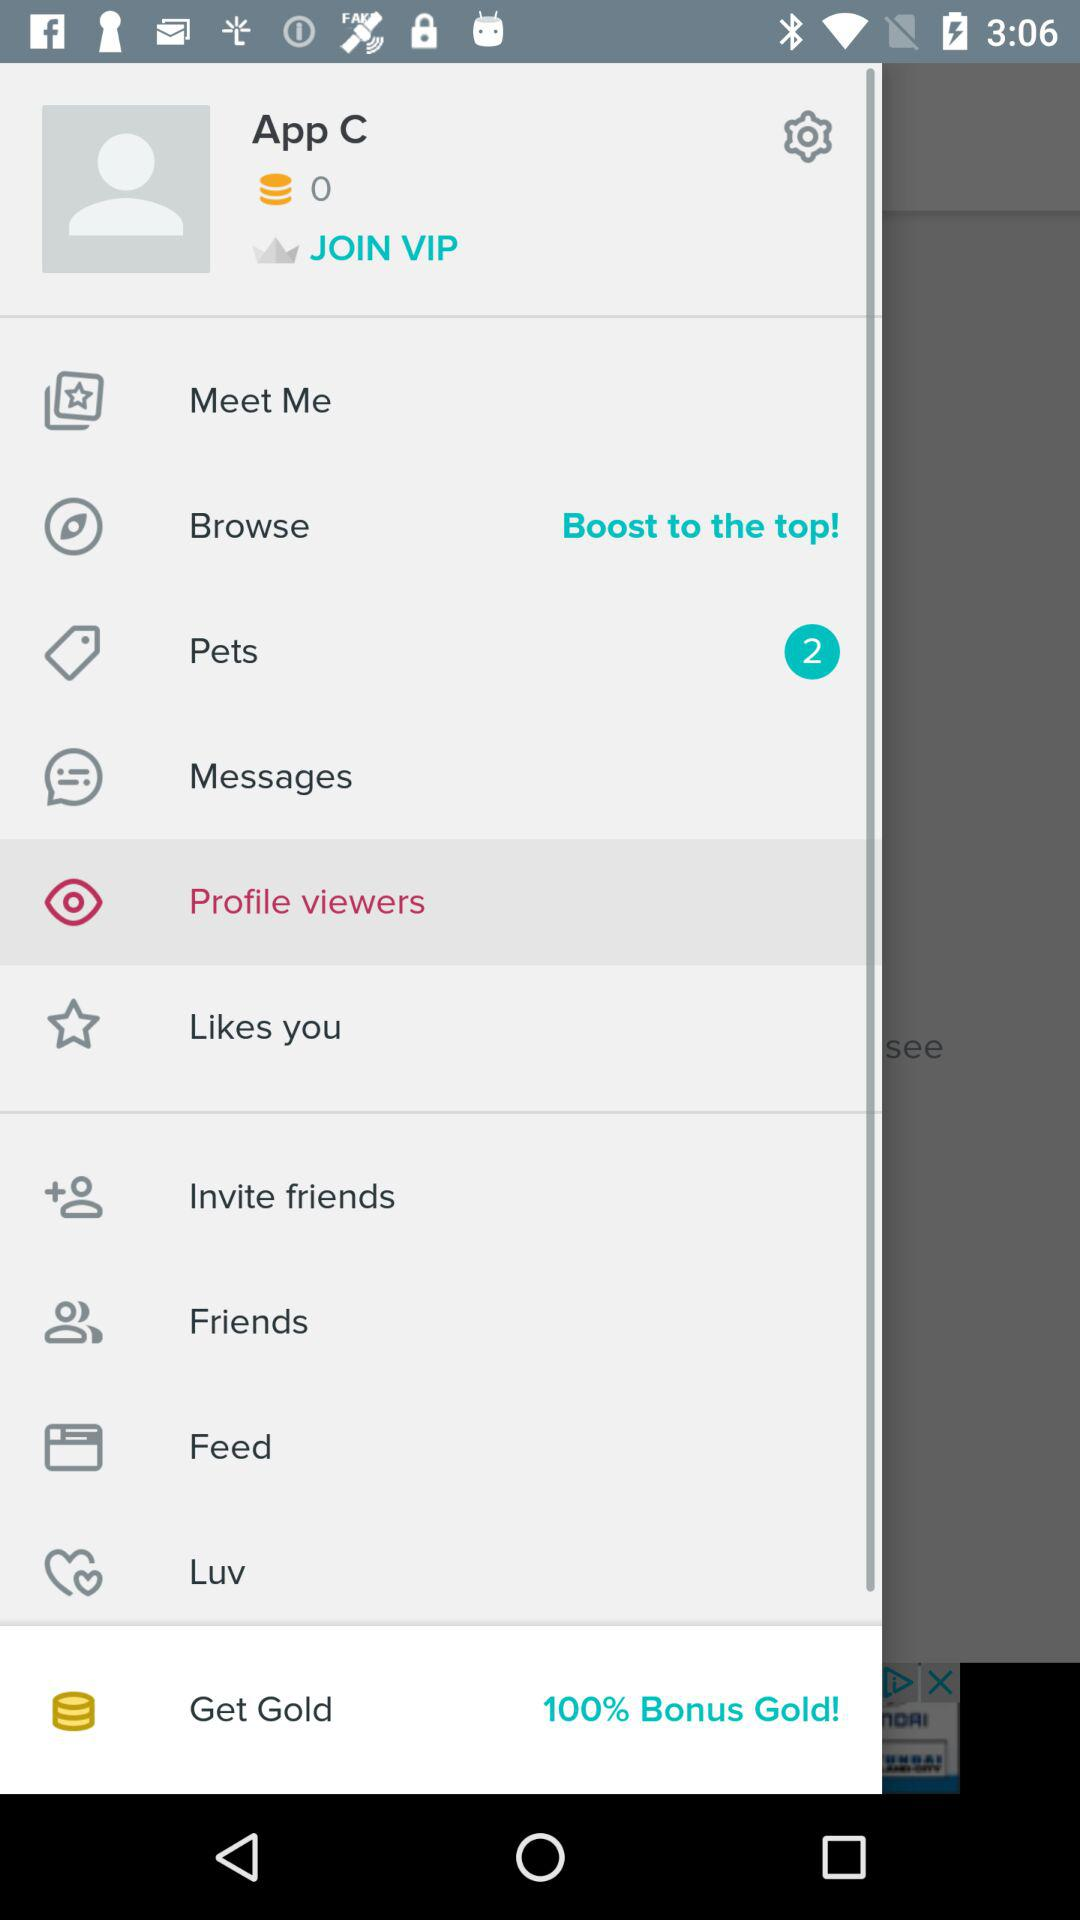What is the name of the user? The name of the user is App C. 